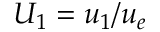<formula> <loc_0><loc_0><loc_500><loc_500>U _ { 1 } = u _ { 1 } / u _ { e }</formula> 